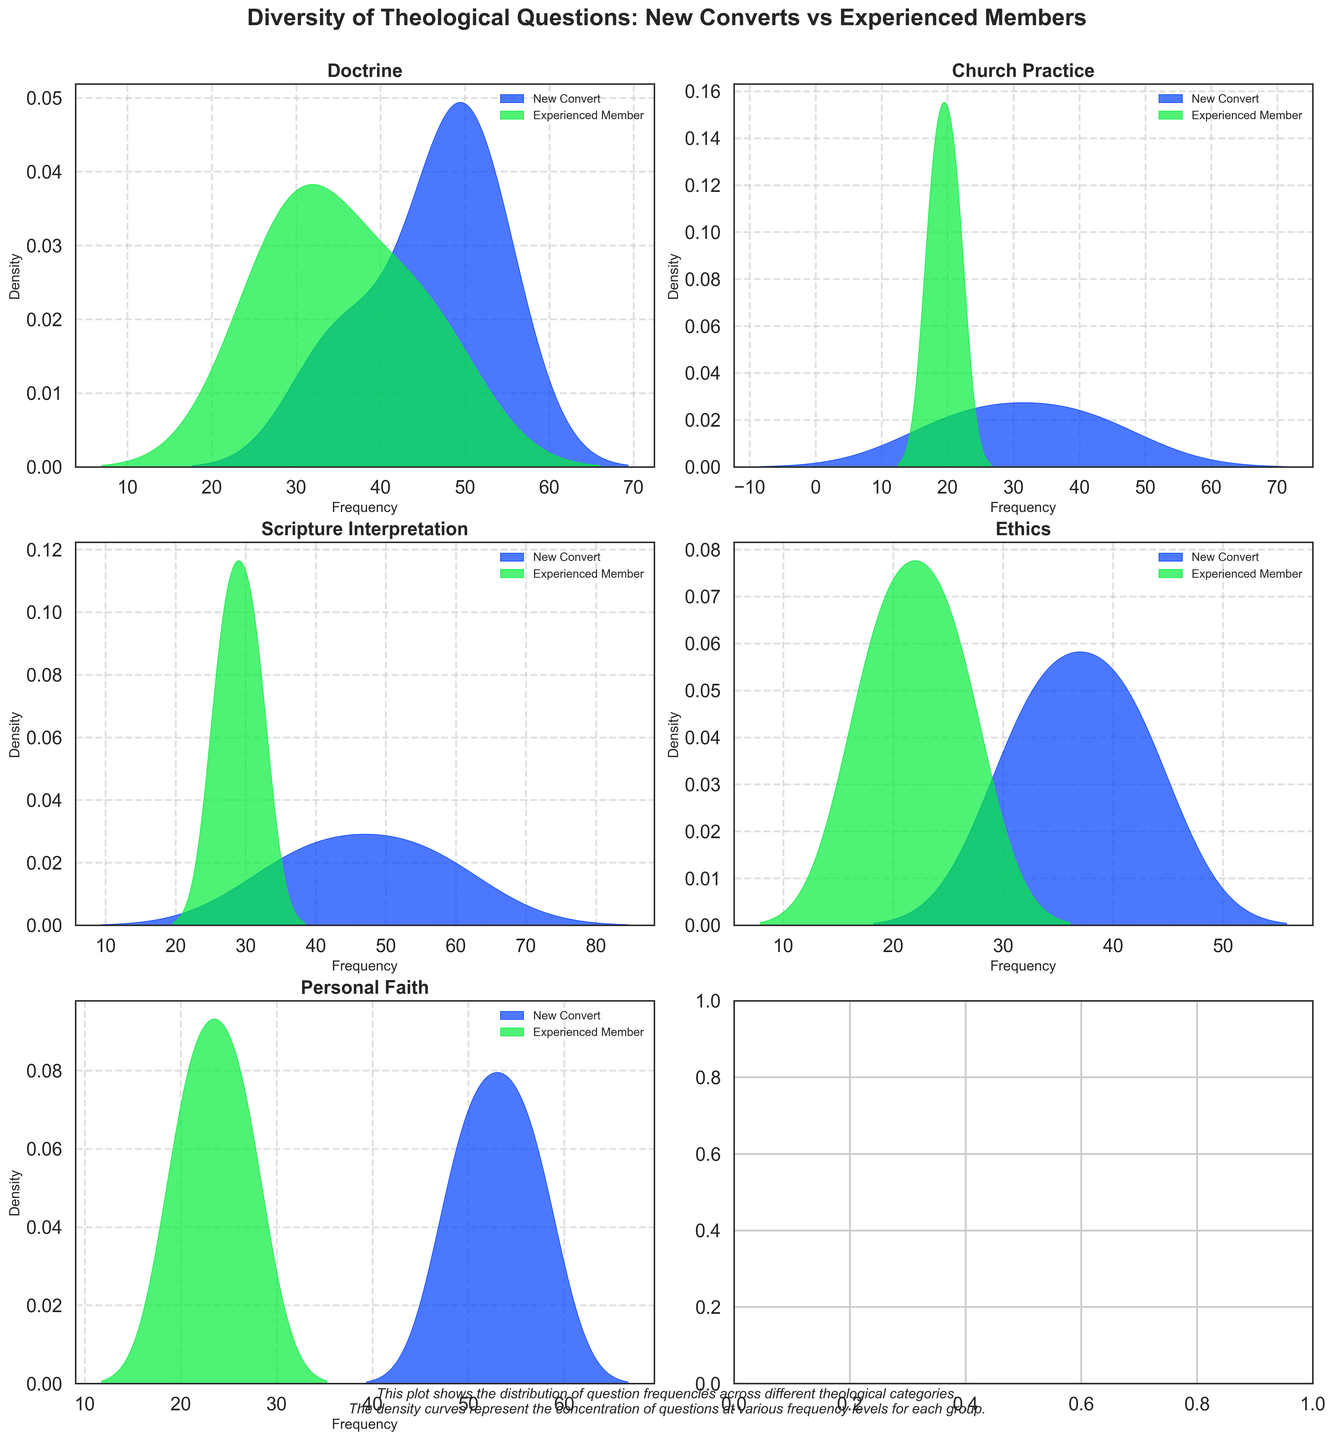What are the categories shown in the figure? The figure shows subplots for different theological categories, which are listed as titles of the individual subplots.
Answer: Doctrine, Church Practice, Scripture Interpretation, Ethics, Personal Faith How do the densities for "Personal Faith" questions compare between new converts and experienced members? Look at the subplot for Personal Faith. The density curves illustrate where the questions are concentrated in terms of frequency.
Answer: New converts have higher density at higher frequencies compared to experienced members Which group has more questions on "Doctrine"? Look at the density plot for Doctrine; compare the height and spread of the density curves for New Converts and Experienced Members.
Answer: New Converts In the subplot for "Ethics," which group has a wider distribution of question frequencies? Observe the width of the density curves for Ethics. A wider curve indicates a wider range of frequencies.
Answer: New Converts Which group tends to ask more frequent questions about "Scripture Interpretation"? Check the peak of the density curves in the Scripture Interpretation subplot. A higher peak indicates more frequent questions at those frequencies.
Answer: New Converts On average, do new converts or experienced members ask more questions about "Church Practice"? Compare the general centrality of the density curves within the subplot for Church Practice.
Answer: New Converts What does the peak in the density curve for experienced members in the "Doctrine" category suggest? A peak in the density curve indicates where most of the data points (question frequencies) are concentrated.
Answer: They focus on questions asked at lower frequencies compared to new converts Can we conclude that experienced members have more diverse question frequencies in any category? Assess the spread and multiple peaks in the density curves for experienced members in each subplot.
Answer: Yes, especially in the Ethics category How does the variation in question frequencies for new converts in "Personal Faith" compare to that in "Church Practice"? Compare the spread (width) and height of the density curves for New Converts in Personal Faith and Church Practice.
Answer: More variation in Personal Faith than in Church Practice Is there a theological category where both groups show similar density distribution? Look for subplots where the density curves of New Converts and Experienced Members overlap significantly.
Answer: No obvious category 